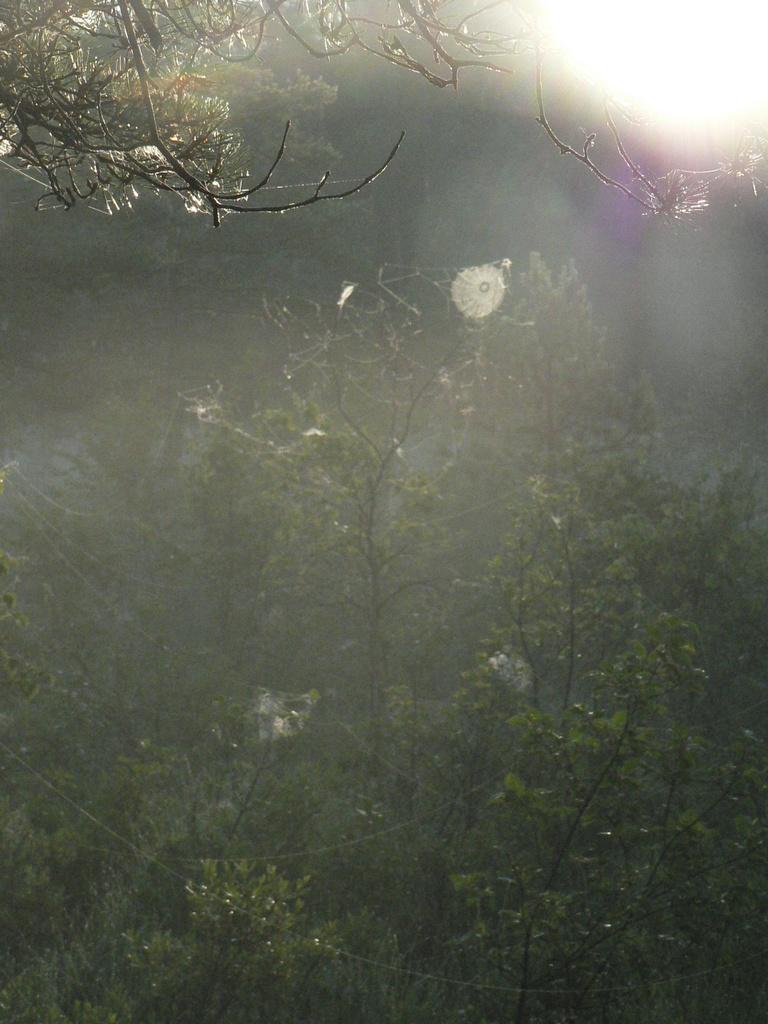Could you give a brief overview of what you see in this image? In this picture we can see trees. In the background of the image it is blurry. 